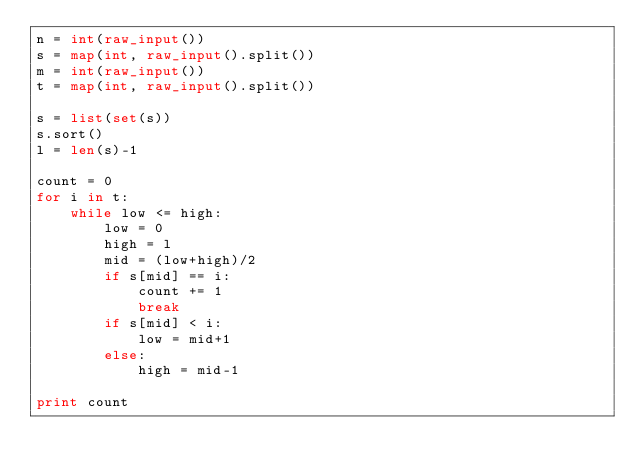Convert code to text. <code><loc_0><loc_0><loc_500><loc_500><_Python_>n = int(raw_input())
s = map(int, raw_input().split())
m = int(raw_input())
t = map(int, raw_input().split())

s = list(set(s))
s.sort()
l = len(s)-1

count = 0
for i in t:
    while low <= high:
        low = 0
        high = l
        mid = (low+high)/2
        if s[mid] == i:
            count += 1
            break
        if s[mid] < i:
            low = mid+1
        else:
            high = mid-1

print count</code> 